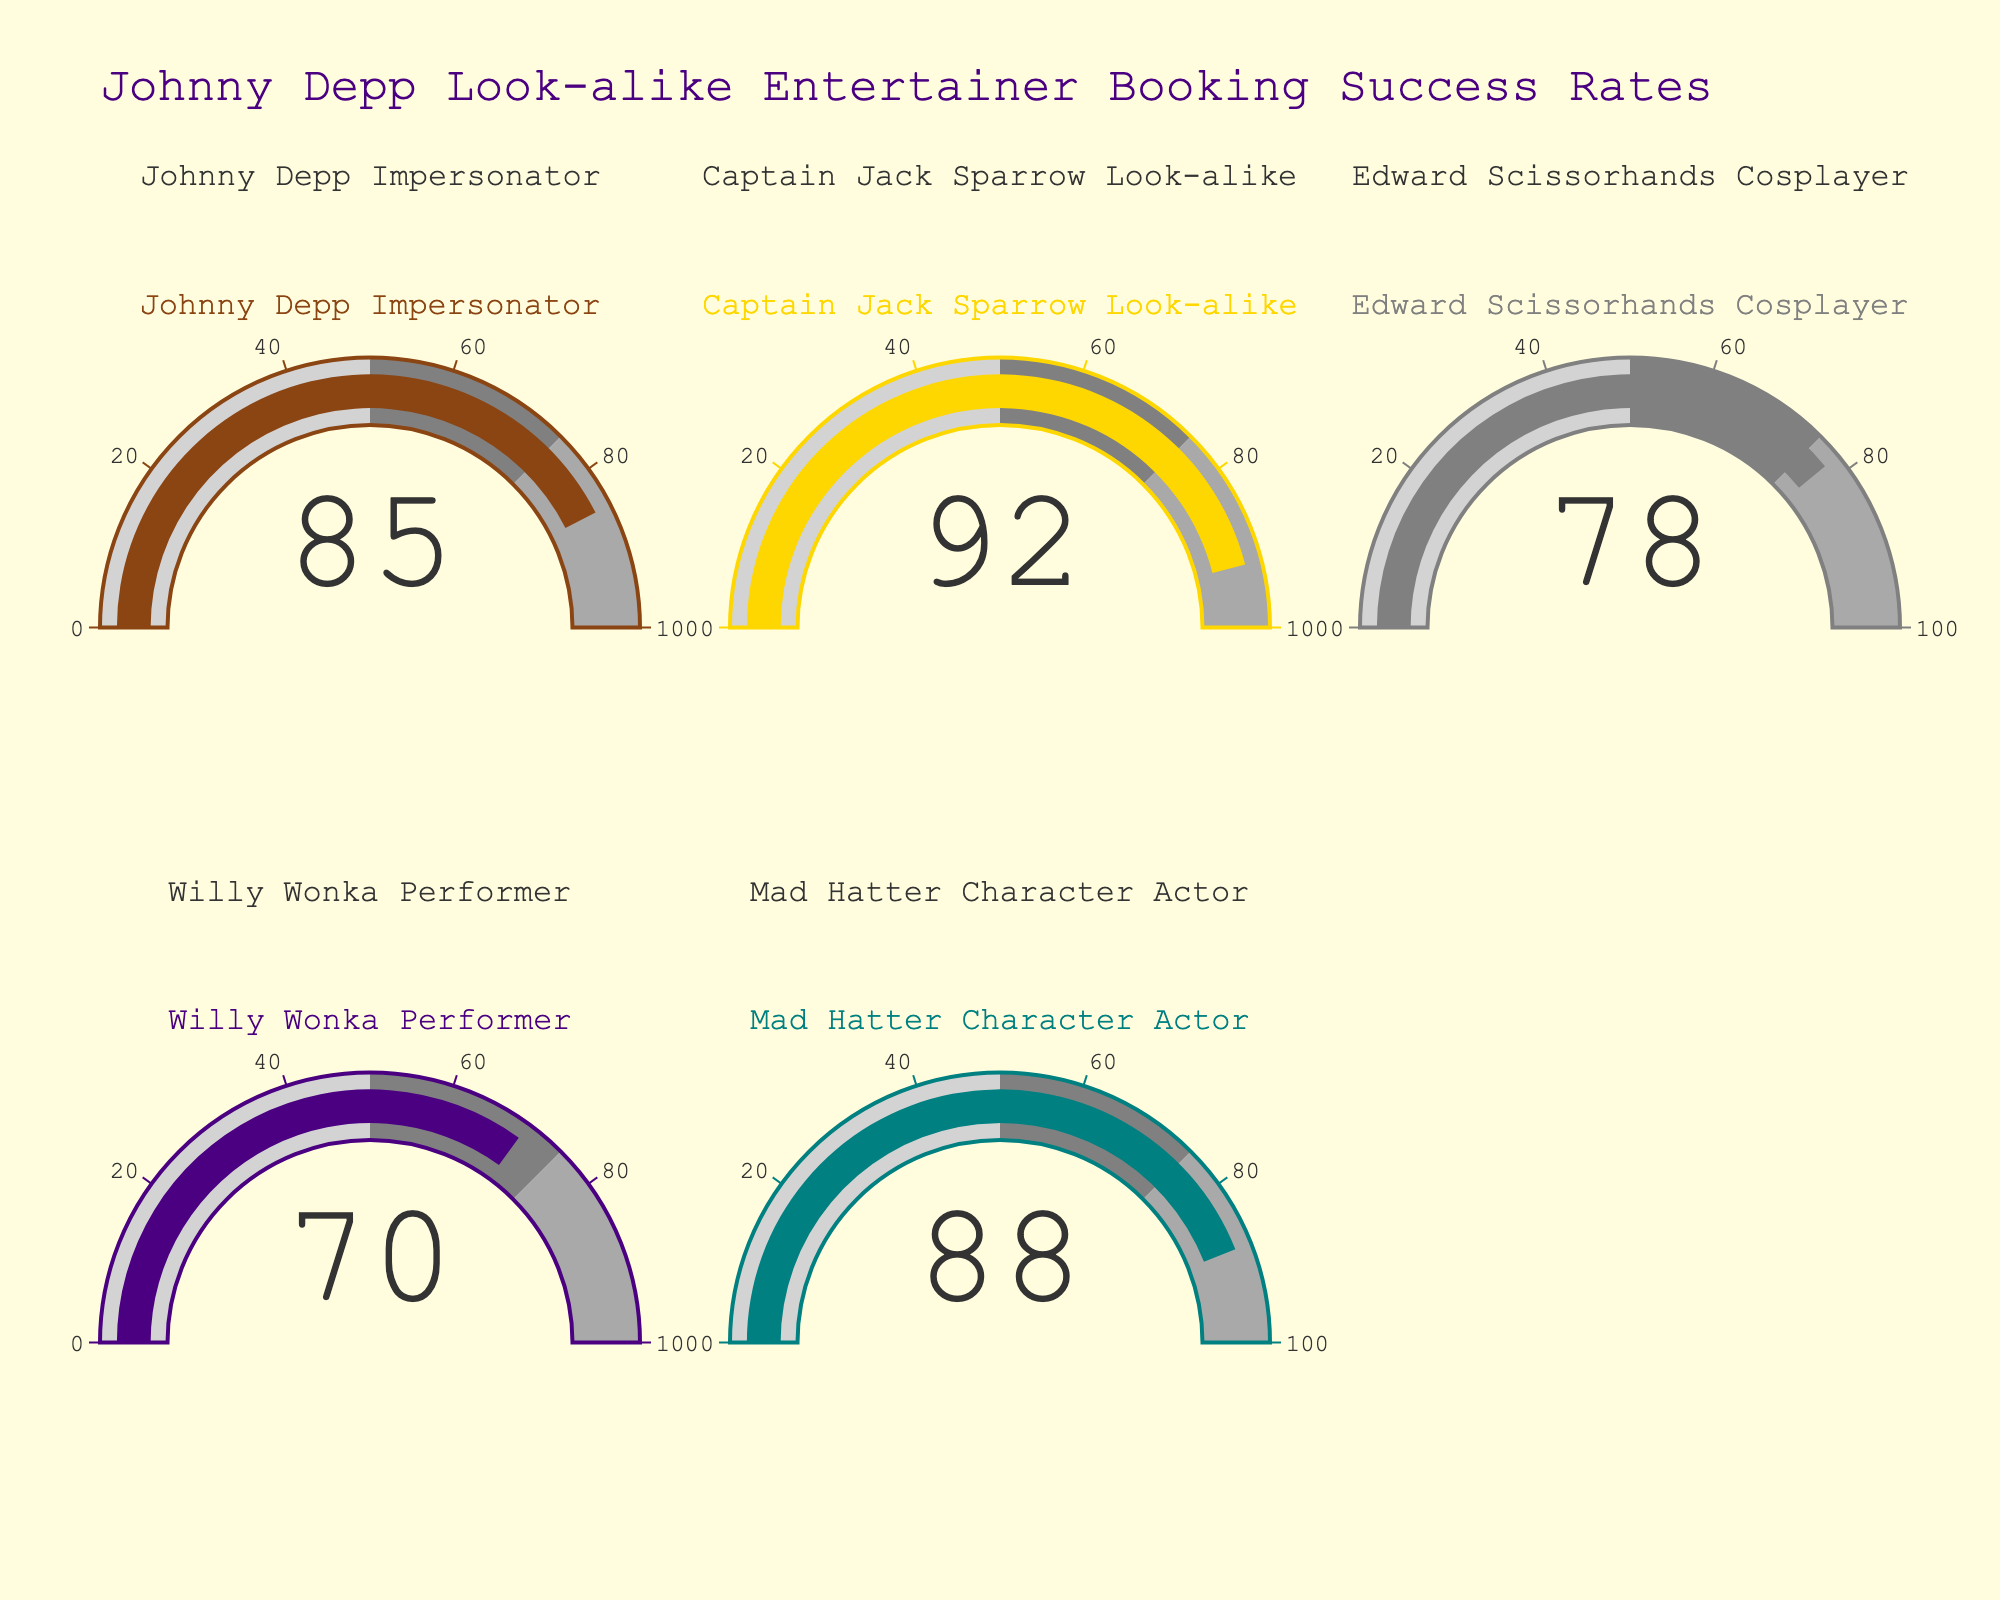Which entertainer has the highest success rate? The gauge chart shows the success rates of various Johnny Depp look-alikes. The one with the highest success rate is the Captain Jack Sparrow Look-alike.
Answer: Captain Jack Sparrow Look-alike Which entertainer has the lowest success rate? Among the entertainers shown in the gauge chart, the one with the lowest success rate is the Willy Wonka Performer.
Answer: Willy Wonka Performer What is the average success rate of all the entertainers? To find the average, add the success rates of all the entertainers and divide by the number of entertainers. (85 + 92 + 78 + 70 + 88) / 5 = 82.6
Answer: 82.6 How many entertainers have a success rate higher than 80%? From the gauge chart, check each success rate and count how many are above 80. They are: Johnny Depp Impersonator, Captain Jack Sparrow Look-alike, and Mad Hatter Character Actor. There are 3 in total.
Answer: 3 What's the difference between the success rates of the highest and the lowest? Subtract the lowest success rate (Willy Wonka Performer: 70) from the highest success rate (Captain Jack Sparrow Look-alike: 92). 92 - 70 = 22
Answer: 22 If the threshold for a high success rate is 75%, how many entertainers meet this criterion? From the gauge chart, identify the success rates over 75%: Johnny Depp Impersonator, Captain Jack Sparrow Look-alike, Edward Scissorhands Cosplayer, and Mad Hatter Character Actor. There are 4 entertainers in total.
Answer: 4 Which two entertainers have the closest success rates to each other? By examining the success rates, the Johnny Depp Impersonator (85) and the Mad Hatter Character Actor (88) have the closest success rates, with a difference of 3.
Answer: Johnny Depp Impersonator and Mad Hatter Character Actor Which entertainer shows a success rate close to the average success rate? The average success rate calculated earlier is 82.6. The gauge chart shows that the Johnny Depp Impersonator has a success rate of 85, which is closest to 82.6.
Answer: Johnny Depp Impersonator 